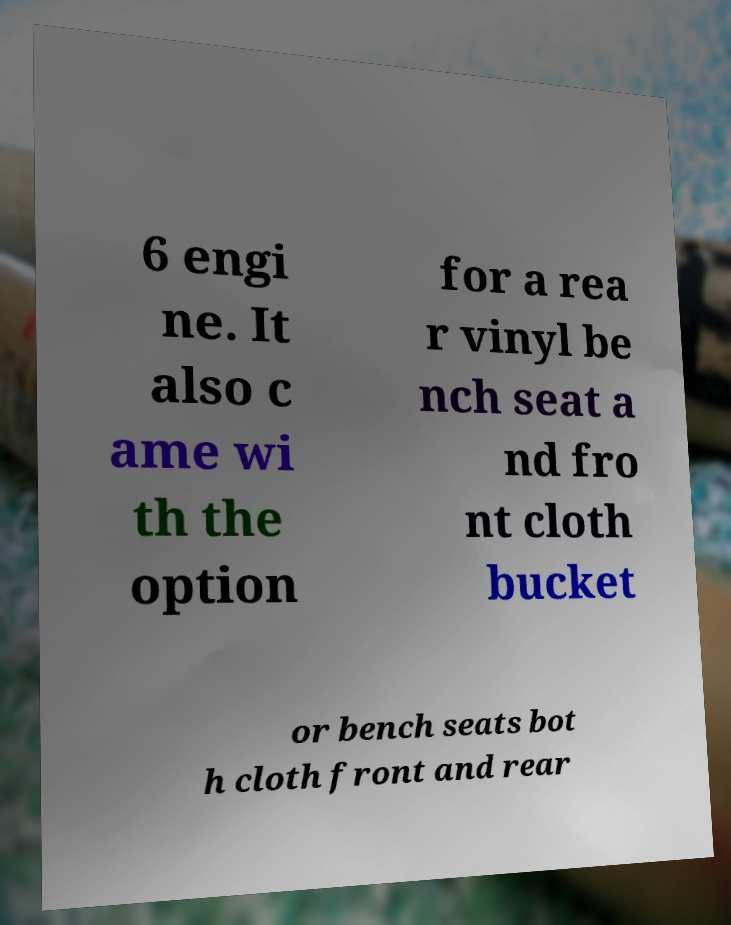For documentation purposes, I need the text within this image transcribed. Could you provide that? 6 engi ne. It also c ame wi th the option for a rea r vinyl be nch seat a nd fro nt cloth bucket or bench seats bot h cloth front and rear 